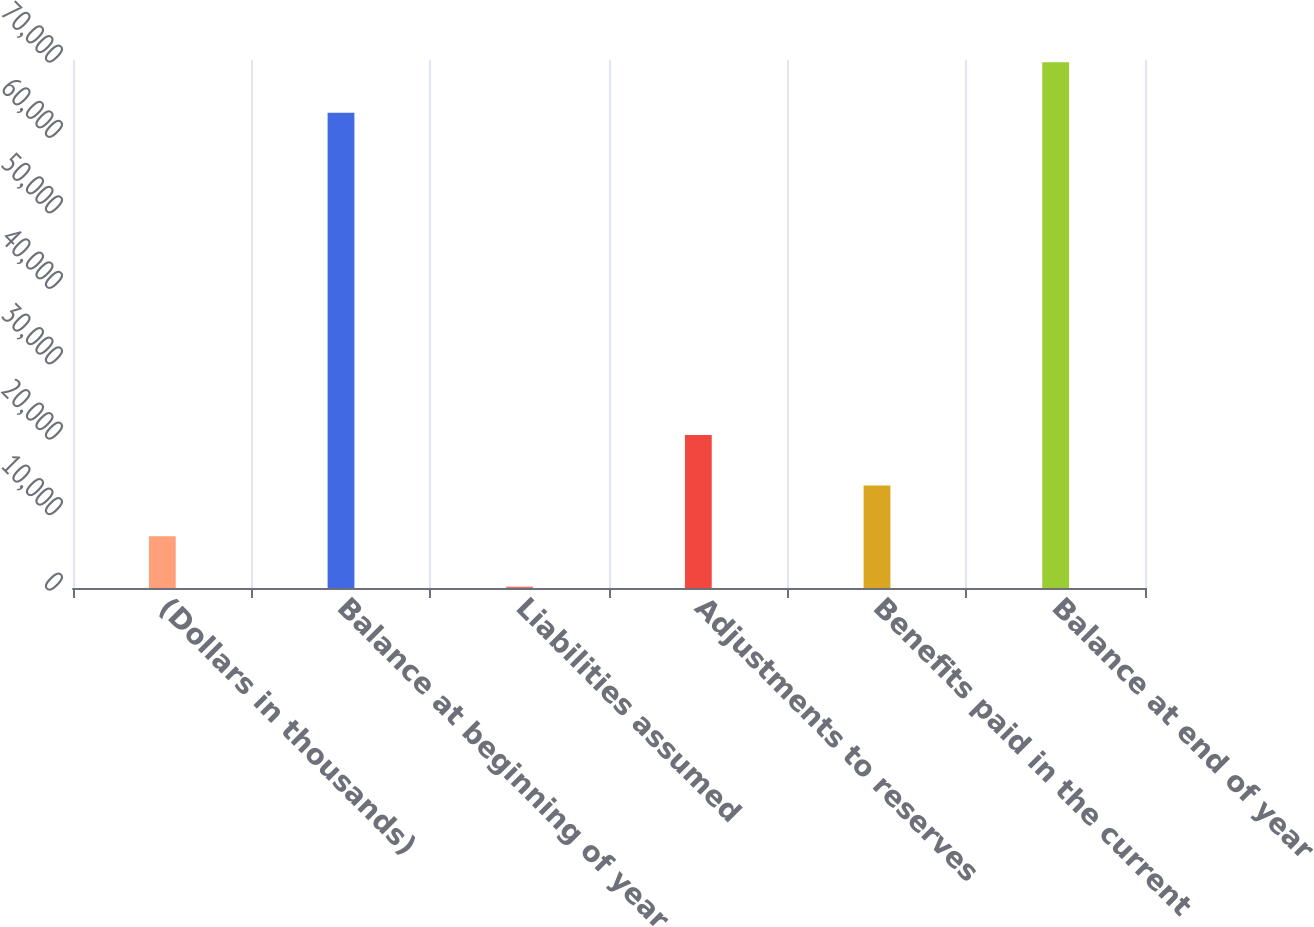Convert chart to OTSL. <chart><loc_0><loc_0><loc_500><loc_500><bar_chart><fcel>(Dollars in thousands)<fcel>Balance at beginning of year<fcel>Liabilities assumed<fcel>Adjustments to reserves<fcel>Benefits paid in the current<fcel>Balance at end of year<nl><fcel>6877.1<fcel>63002<fcel>176<fcel>20279.3<fcel>13578.2<fcel>69703.1<nl></chart> 